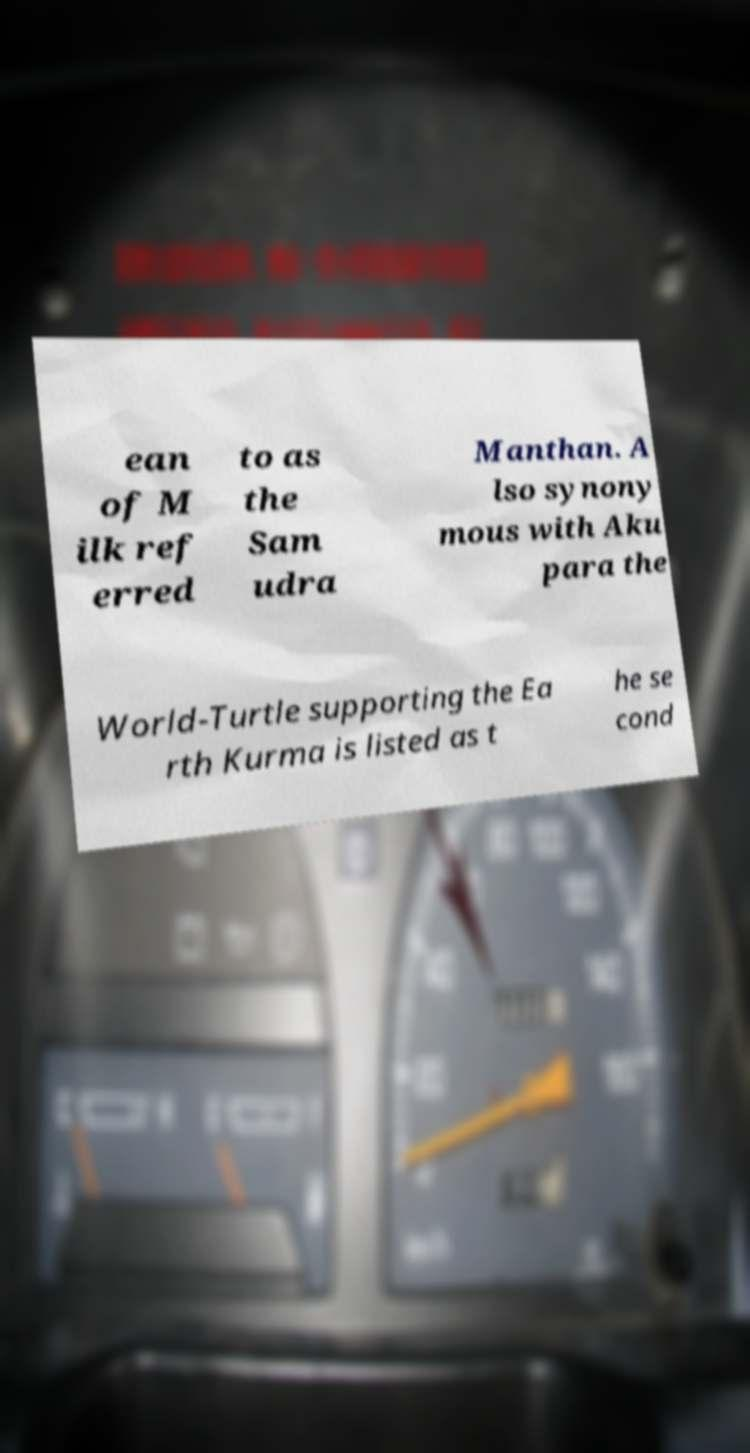Could you assist in decoding the text presented in this image and type it out clearly? ean of M ilk ref erred to as the Sam udra Manthan. A lso synony mous with Aku para the World-Turtle supporting the Ea rth Kurma is listed as t he se cond 